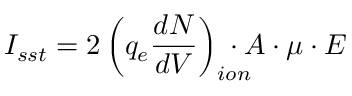Convert formula to latex. <formula><loc_0><loc_0><loc_500><loc_500>I _ { s s t } = 2 \left ( q _ { e } \frac { d N } { d V } \right ) _ { i o n } \, \cdot A \cdot \mu \cdot E</formula> 